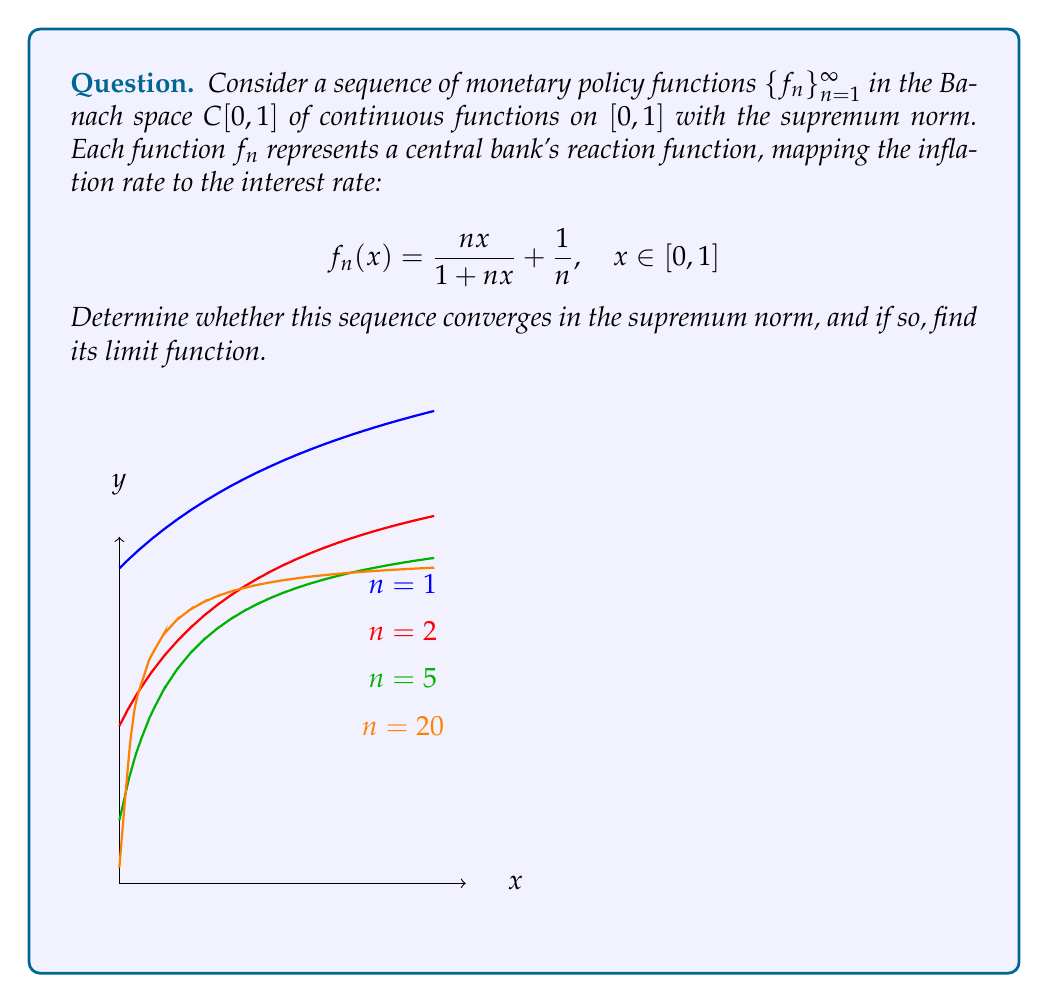Provide a solution to this math problem. Let's approach this step-by-step:

1) First, we need to find the pointwise limit of $f_n(x)$ as $n \to \infty$:

   $$\lim_{n\to\infty} f_n(x) = \lim_{n\to\infty} \left(\frac{nx}{1+nx} + \frac{1}{n}\right) = \lim_{n\to\infty} \frac{nx}{1+nx} + \lim_{n\to\infty} \frac{1}{n} = \frac{x}{x} + 0 = 1$$

   for $x \neq 0$, and $\lim_{n\to\infty} f_n(0) = 0$.

2) So, the pointwise limit function is:

   $$f(x) = \begin{cases} 1 & \text{if } x \in (0,1] \\ 0 & \text{if } x = 0 \end{cases}$$

3) Now, we need to check if the convergence is uniform. For this, we'll examine:

   $$\sup_{x\in[0,1]} |f_n(x) - f(x)|$$

4) For $x \in (0,1]$:
   
   $$|f_n(x) - f(x)| = \left|\frac{nx}{1+nx} + \frac{1}{n} - 1\right| = \left|\frac{1}{1+nx} + \frac{1}{n}\right| \leq \frac{1}{n} + \frac{1}{n} = \frac{2}{n}$$

5) For $x = 0$:
   
   $$|f_n(0) - f(0)| = \left|\frac{1}{n} - 0\right| = \frac{1}{n}$$

6) Therefore:

   $$\sup_{x\in[0,1]} |f_n(x) - f(x)| \leq \frac{2}{n}$$

7) As $n \to \infty$, this supremum tends to 0, which means the convergence is uniform.

8) Since $C[0,1]$ with the supremum norm is a Banach space and we have uniform convergence, the limit function must also be in $C[0,1]$. However, our pointwise limit $f(x)$ is discontinuous at $x=0$.

9) This contradiction implies that the sequence does not converge in the supremum norm.
Answer: The sequence $\{f_n\}$ does not converge in the supremum norm on $C[0,1]$. 